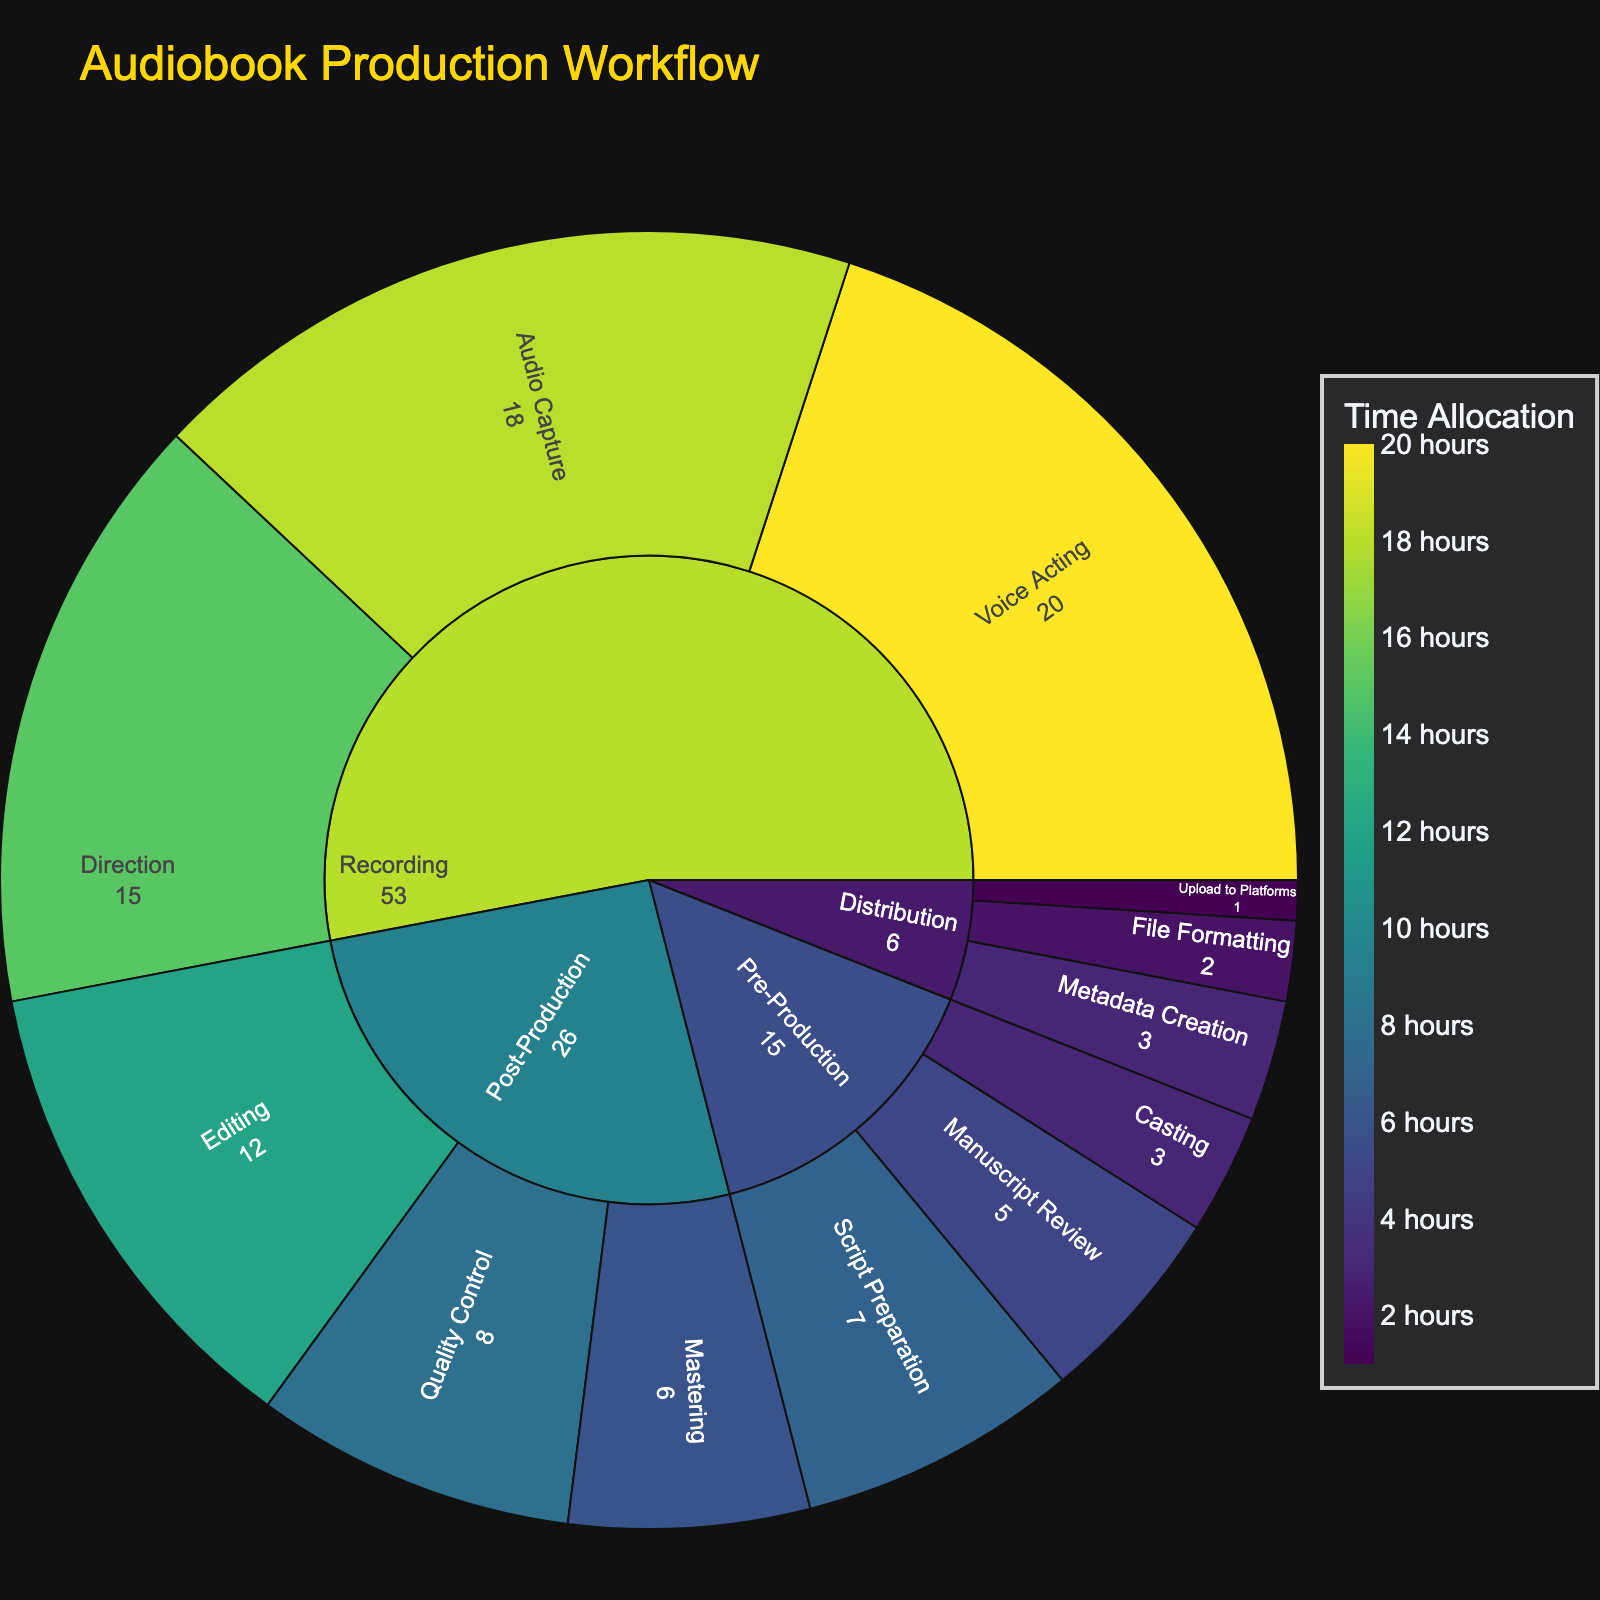What's the title of the figure? The title is usually displayed prominently at the top of the figure. In this case, it should be "Audiobook Production Workflow" based on the given code.
Answer: Audiobook Production Workflow Which stage has the highest time allocation? To find this, sum the time allocations of all substages under each main stage. The stage with the highest total is the answer. For "Recording", Voice Acting (20) + Direction (15) + Audio Capture (18) = 53 hours, which is the highest.
Answer: Recording How much time is allocated to the Pre-Production stage? Sum the time allocations for all substages under Pre-Production: Manuscript Review (5) + Casting (3) + Script Preparation (7).
Answer: 15 hours Which substage under Post-Production takes up the most time? Compare the time allocations for each substage under Post-Production: Editing (12), Quality Control (8), and Mastering (6). The highest value is for Editing.
Answer: Editing Is the time spent on Metadata Creation more or less than that on Casting? Compare the values for Metadata Creation (3) and Casting (3). Both are equal.
Answer: Equal What is the total time spent on Distribution? Sum the time allocations for all substages under Distribution: Metadata Creation (3) + File Formatting (2) + Upload to Platforms (1).
Answer: 6 hours What is the average time spent on each substage in the Recording stage? Sum the times for the Recording substages and divide by the number of substages: (20 + 15 + 18) / 3.
Answer: 17.7 hours Which substage in the Audiobook Production Workflow overall has the highest time allocation? Locate the substage with the highest time allocation in the entire figure, which is Voice Acting with 20 hours.
Answer: Voice Acting What is the combined time spent on Script Preparation and Editing? Add the times for Script Preparation (7) and Editing (12).
Answer: 19 hours How does the time allocation of Quality Control compare to that of Direction? Compare the time allocations: Quality Control (8) and Direction (15). Quality Control has less time allocated compared to Direction.
Answer: Less 